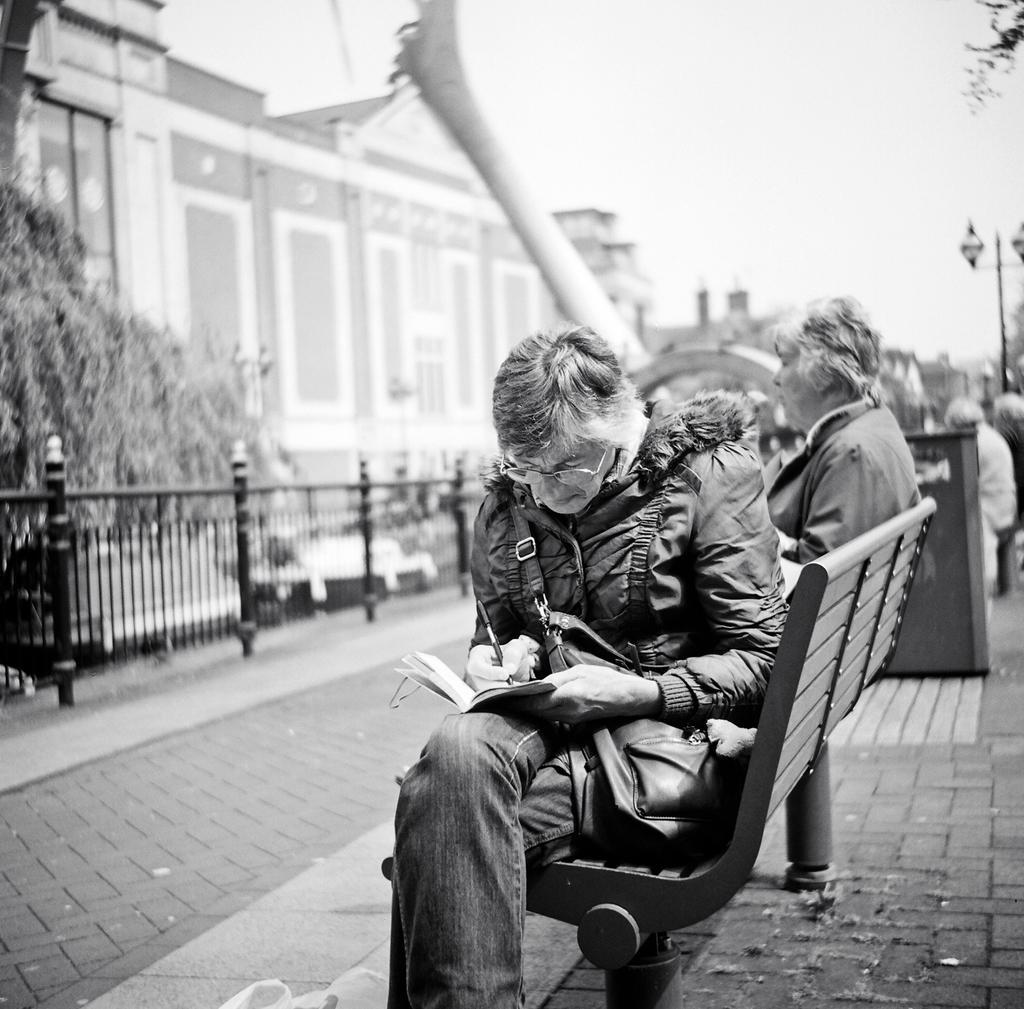Can you describe this image briefly? In this image I can see few people sitting on the benches. These people are wearing the dresses and I can see one person holding the pen and the book. To the left I can see the railing and trees. In the background I can see the building, light pole and the sky. This is a black and white image. 